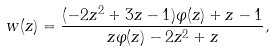<formula> <loc_0><loc_0><loc_500><loc_500>\ w ( z ) = \frac { ( - 2 z ^ { 2 } + 3 z - 1 ) \varphi ( z ) + z - 1 } { z \varphi ( z ) - 2 z ^ { 2 } + z } ,</formula> 